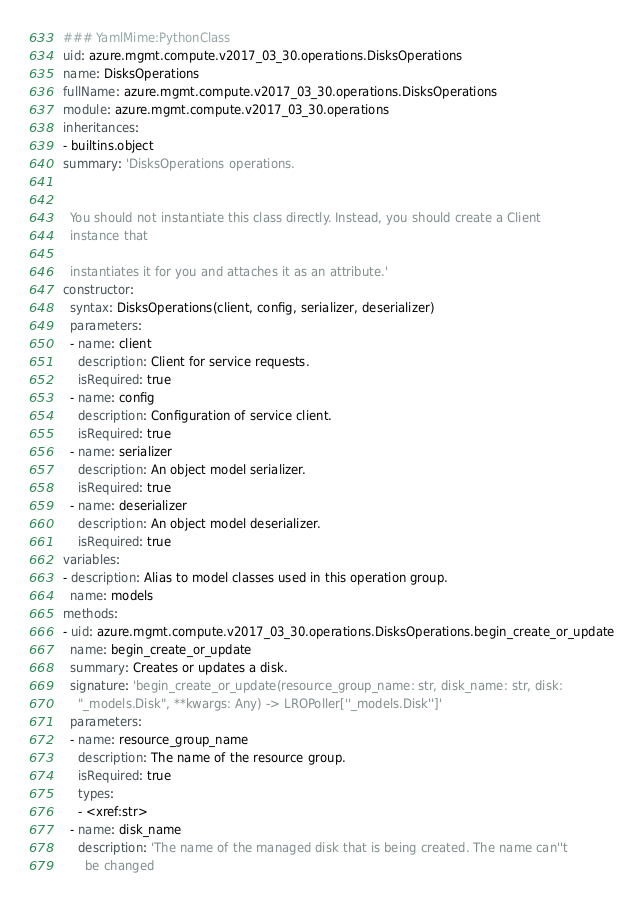Convert code to text. <code><loc_0><loc_0><loc_500><loc_500><_YAML_>### YamlMime:PythonClass
uid: azure.mgmt.compute.v2017_03_30.operations.DisksOperations
name: DisksOperations
fullName: azure.mgmt.compute.v2017_03_30.operations.DisksOperations
module: azure.mgmt.compute.v2017_03_30.operations
inheritances:
- builtins.object
summary: 'DisksOperations operations.


  You should not instantiate this class directly. Instead, you should create a Client
  instance that

  instantiates it for you and attaches it as an attribute.'
constructor:
  syntax: DisksOperations(client, config, serializer, deserializer)
  parameters:
  - name: client
    description: Client for service requests.
    isRequired: true
  - name: config
    description: Configuration of service client.
    isRequired: true
  - name: serializer
    description: An object model serializer.
    isRequired: true
  - name: deserializer
    description: An object model deserializer.
    isRequired: true
variables:
- description: Alias to model classes used in this operation group.
  name: models
methods:
- uid: azure.mgmt.compute.v2017_03_30.operations.DisksOperations.begin_create_or_update
  name: begin_create_or_update
  summary: Creates or updates a disk.
  signature: 'begin_create_or_update(resource_group_name: str, disk_name: str, disk:
    "_models.Disk", **kwargs: Any) -> LROPoller[''_models.Disk'']'
  parameters:
  - name: resource_group_name
    description: The name of the resource group.
    isRequired: true
    types:
    - <xref:str>
  - name: disk_name
    description: 'The name of the managed disk that is being created. The name can''t
      be changed
</code> 